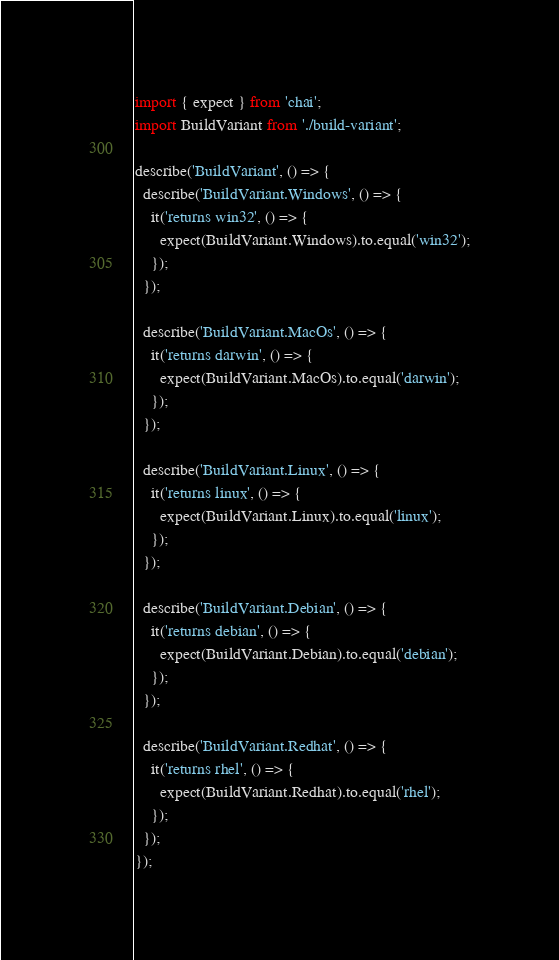Convert code to text. <code><loc_0><loc_0><loc_500><loc_500><_TypeScript_>import { expect } from 'chai';
import BuildVariant from './build-variant';

describe('BuildVariant', () => {
  describe('BuildVariant.Windows', () => {
    it('returns win32', () => {
      expect(BuildVariant.Windows).to.equal('win32');
    });
  });

  describe('BuildVariant.MacOs', () => {
    it('returns darwin', () => {
      expect(BuildVariant.MacOs).to.equal('darwin');
    });
  });

  describe('BuildVariant.Linux', () => {
    it('returns linux', () => {
      expect(BuildVariant.Linux).to.equal('linux');
    });
  });

  describe('BuildVariant.Debian', () => {
    it('returns debian', () => {
      expect(BuildVariant.Debian).to.equal('debian');
    });
  });

  describe('BuildVariant.Redhat', () => {
    it('returns rhel', () => {
      expect(BuildVariant.Redhat).to.equal('rhel');
    });
  });
});
</code> 